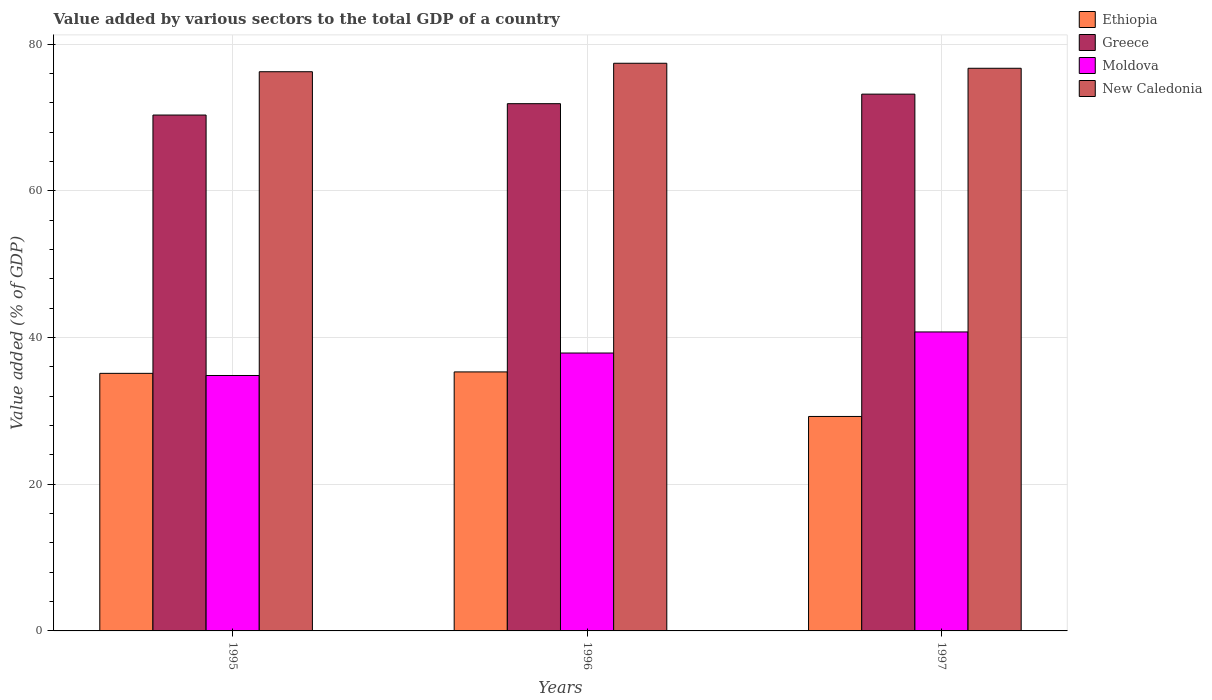How many groups of bars are there?
Offer a terse response. 3. Are the number of bars on each tick of the X-axis equal?
Make the answer very short. Yes. How many bars are there on the 1st tick from the right?
Give a very brief answer. 4. What is the label of the 2nd group of bars from the left?
Offer a terse response. 1996. In how many cases, is the number of bars for a given year not equal to the number of legend labels?
Offer a terse response. 0. What is the value added by various sectors to the total GDP in New Caledonia in 1996?
Make the answer very short. 77.4. Across all years, what is the maximum value added by various sectors to the total GDP in Moldova?
Your answer should be compact. 40.76. Across all years, what is the minimum value added by various sectors to the total GDP in Ethiopia?
Give a very brief answer. 29.24. In which year was the value added by various sectors to the total GDP in Ethiopia minimum?
Your answer should be compact. 1997. What is the total value added by various sectors to the total GDP in Ethiopia in the graph?
Make the answer very short. 99.67. What is the difference between the value added by various sectors to the total GDP in Ethiopia in 1995 and that in 1996?
Provide a short and direct response. -0.2. What is the difference between the value added by various sectors to the total GDP in Ethiopia in 1997 and the value added by various sectors to the total GDP in New Caledonia in 1995?
Your answer should be compact. -47. What is the average value added by various sectors to the total GDP in Moldova per year?
Provide a short and direct response. 37.83. In the year 1995, what is the difference between the value added by various sectors to the total GDP in Ethiopia and value added by various sectors to the total GDP in New Caledonia?
Your response must be concise. -41.12. In how many years, is the value added by various sectors to the total GDP in New Caledonia greater than 36 %?
Keep it short and to the point. 3. What is the ratio of the value added by various sectors to the total GDP in New Caledonia in 1995 to that in 1996?
Keep it short and to the point. 0.99. Is the value added by various sectors to the total GDP in Moldova in 1996 less than that in 1997?
Ensure brevity in your answer.  Yes. What is the difference between the highest and the second highest value added by various sectors to the total GDP in New Caledonia?
Your answer should be very brief. 0.68. What is the difference between the highest and the lowest value added by various sectors to the total GDP in New Caledonia?
Keep it short and to the point. 1.15. In how many years, is the value added by various sectors to the total GDP in Ethiopia greater than the average value added by various sectors to the total GDP in Ethiopia taken over all years?
Your answer should be very brief. 2. Is the sum of the value added by various sectors to the total GDP in Ethiopia in 1996 and 1997 greater than the maximum value added by various sectors to the total GDP in New Caledonia across all years?
Ensure brevity in your answer.  No. What does the 1st bar from the left in 1995 represents?
Provide a short and direct response. Ethiopia. What does the 3rd bar from the right in 1995 represents?
Make the answer very short. Greece. How many bars are there?
Your answer should be compact. 12. Are all the bars in the graph horizontal?
Make the answer very short. No. What is the difference between two consecutive major ticks on the Y-axis?
Your response must be concise. 20. Are the values on the major ticks of Y-axis written in scientific E-notation?
Provide a succinct answer. No. Does the graph contain any zero values?
Your answer should be compact. No. Where does the legend appear in the graph?
Give a very brief answer. Top right. How are the legend labels stacked?
Ensure brevity in your answer.  Vertical. What is the title of the graph?
Your answer should be compact. Value added by various sectors to the total GDP of a country. Does "North America" appear as one of the legend labels in the graph?
Keep it short and to the point. No. What is the label or title of the Y-axis?
Give a very brief answer. Value added (% of GDP). What is the Value added (% of GDP) in Ethiopia in 1995?
Offer a very short reply. 35.12. What is the Value added (% of GDP) in Greece in 1995?
Provide a short and direct response. 70.34. What is the Value added (% of GDP) in Moldova in 1995?
Offer a very short reply. 34.83. What is the Value added (% of GDP) in New Caledonia in 1995?
Make the answer very short. 76.24. What is the Value added (% of GDP) of Ethiopia in 1996?
Offer a very short reply. 35.31. What is the Value added (% of GDP) in Greece in 1996?
Give a very brief answer. 71.89. What is the Value added (% of GDP) of Moldova in 1996?
Make the answer very short. 37.89. What is the Value added (% of GDP) in New Caledonia in 1996?
Offer a terse response. 77.4. What is the Value added (% of GDP) in Ethiopia in 1997?
Provide a succinct answer. 29.24. What is the Value added (% of GDP) in Greece in 1997?
Ensure brevity in your answer.  73.19. What is the Value added (% of GDP) in Moldova in 1997?
Make the answer very short. 40.76. What is the Value added (% of GDP) of New Caledonia in 1997?
Offer a terse response. 76.71. Across all years, what is the maximum Value added (% of GDP) in Ethiopia?
Keep it short and to the point. 35.31. Across all years, what is the maximum Value added (% of GDP) in Greece?
Provide a short and direct response. 73.19. Across all years, what is the maximum Value added (% of GDP) of Moldova?
Offer a terse response. 40.76. Across all years, what is the maximum Value added (% of GDP) of New Caledonia?
Your answer should be compact. 77.4. Across all years, what is the minimum Value added (% of GDP) in Ethiopia?
Provide a succinct answer. 29.24. Across all years, what is the minimum Value added (% of GDP) in Greece?
Offer a very short reply. 70.34. Across all years, what is the minimum Value added (% of GDP) in Moldova?
Your response must be concise. 34.83. Across all years, what is the minimum Value added (% of GDP) of New Caledonia?
Ensure brevity in your answer.  76.24. What is the total Value added (% of GDP) in Ethiopia in the graph?
Provide a short and direct response. 99.67. What is the total Value added (% of GDP) in Greece in the graph?
Your answer should be very brief. 215.41. What is the total Value added (% of GDP) in Moldova in the graph?
Make the answer very short. 113.48. What is the total Value added (% of GDP) in New Caledonia in the graph?
Offer a terse response. 230.36. What is the difference between the Value added (% of GDP) in Ethiopia in 1995 and that in 1996?
Offer a very short reply. -0.2. What is the difference between the Value added (% of GDP) in Greece in 1995 and that in 1996?
Your answer should be compact. -1.55. What is the difference between the Value added (% of GDP) of Moldova in 1995 and that in 1996?
Give a very brief answer. -3.06. What is the difference between the Value added (% of GDP) of New Caledonia in 1995 and that in 1996?
Your answer should be very brief. -1.15. What is the difference between the Value added (% of GDP) in Ethiopia in 1995 and that in 1997?
Offer a terse response. 5.88. What is the difference between the Value added (% of GDP) of Greece in 1995 and that in 1997?
Your answer should be very brief. -2.85. What is the difference between the Value added (% of GDP) in Moldova in 1995 and that in 1997?
Make the answer very short. -5.94. What is the difference between the Value added (% of GDP) of New Caledonia in 1995 and that in 1997?
Offer a very short reply. -0.47. What is the difference between the Value added (% of GDP) of Ethiopia in 1996 and that in 1997?
Your answer should be compact. 6.07. What is the difference between the Value added (% of GDP) of Greece in 1996 and that in 1997?
Provide a short and direct response. -1.3. What is the difference between the Value added (% of GDP) in Moldova in 1996 and that in 1997?
Offer a very short reply. -2.87. What is the difference between the Value added (% of GDP) of New Caledonia in 1996 and that in 1997?
Your response must be concise. 0.68. What is the difference between the Value added (% of GDP) of Ethiopia in 1995 and the Value added (% of GDP) of Greece in 1996?
Offer a very short reply. -36.77. What is the difference between the Value added (% of GDP) of Ethiopia in 1995 and the Value added (% of GDP) of Moldova in 1996?
Your answer should be very brief. -2.77. What is the difference between the Value added (% of GDP) in Ethiopia in 1995 and the Value added (% of GDP) in New Caledonia in 1996?
Provide a short and direct response. -42.28. What is the difference between the Value added (% of GDP) in Greece in 1995 and the Value added (% of GDP) in Moldova in 1996?
Keep it short and to the point. 32.45. What is the difference between the Value added (% of GDP) of Greece in 1995 and the Value added (% of GDP) of New Caledonia in 1996?
Offer a very short reply. -7.06. What is the difference between the Value added (% of GDP) in Moldova in 1995 and the Value added (% of GDP) in New Caledonia in 1996?
Provide a succinct answer. -42.57. What is the difference between the Value added (% of GDP) of Ethiopia in 1995 and the Value added (% of GDP) of Greece in 1997?
Make the answer very short. -38.07. What is the difference between the Value added (% of GDP) in Ethiopia in 1995 and the Value added (% of GDP) in Moldova in 1997?
Ensure brevity in your answer.  -5.65. What is the difference between the Value added (% of GDP) of Ethiopia in 1995 and the Value added (% of GDP) of New Caledonia in 1997?
Make the answer very short. -41.6. What is the difference between the Value added (% of GDP) of Greece in 1995 and the Value added (% of GDP) of Moldova in 1997?
Provide a succinct answer. 29.57. What is the difference between the Value added (% of GDP) in Greece in 1995 and the Value added (% of GDP) in New Caledonia in 1997?
Give a very brief answer. -6.38. What is the difference between the Value added (% of GDP) of Moldova in 1995 and the Value added (% of GDP) of New Caledonia in 1997?
Provide a short and direct response. -41.89. What is the difference between the Value added (% of GDP) in Ethiopia in 1996 and the Value added (% of GDP) in Greece in 1997?
Offer a very short reply. -37.87. What is the difference between the Value added (% of GDP) in Ethiopia in 1996 and the Value added (% of GDP) in Moldova in 1997?
Provide a succinct answer. -5.45. What is the difference between the Value added (% of GDP) of Ethiopia in 1996 and the Value added (% of GDP) of New Caledonia in 1997?
Offer a very short reply. -41.4. What is the difference between the Value added (% of GDP) of Greece in 1996 and the Value added (% of GDP) of Moldova in 1997?
Your answer should be very brief. 31.12. What is the difference between the Value added (% of GDP) of Greece in 1996 and the Value added (% of GDP) of New Caledonia in 1997?
Give a very brief answer. -4.83. What is the difference between the Value added (% of GDP) of Moldova in 1996 and the Value added (% of GDP) of New Caledonia in 1997?
Ensure brevity in your answer.  -38.82. What is the average Value added (% of GDP) of Ethiopia per year?
Ensure brevity in your answer.  33.22. What is the average Value added (% of GDP) of Greece per year?
Provide a short and direct response. 71.8. What is the average Value added (% of GDP) of Moldova per year?
Your response must be concise. 37.83. What is the average Value added (% of GDP) of New Caledonia per year?
Keep it short and to the point. 76.78. In the year 1995, what is the difference between the Value added (% of GDP) in Ethiopia and Value added (% of GDP) in Greece?
Provide a short and direct response. -35.22. In the year 1995, what is the difference between the Value added (% of GDP) in Ethiopia and Value added (% of GDP) in Moldova?
Make the answer very short. 0.29. In the year 1995, what is the difference between the Value added (% of GDP) in Ethiopia and Value added (% of GDP) in New Caledonia?
Your answer should be very brief. -41.12. In the year 1995, what is the difference between the Value added (% of GDP) in Greece and Value added (% of GDP) in Moldova?
Your answer should be very brief. 35.51. In the year 1995, what is the difference between the Value added (% of GDP) of Greece and Value added (% of GDP) of New Caledonia?
Make the answer very short. -5.91. In the year 1995, what is the difference between the Value added (% of GDP) of Moldova and Value added (% of GDP) of New Caledonia?
Offer a terse response. -41.42. In the year 1996, what is the difference between the Value added (% of GDP) in Ethiopia and Value added (% of GDP) in Greece?
Keep it short and to the point. -36.57. In the year 1996, what is the difference between the Value added (% of GDP) in Ethiopia and Value added (% of GDP) in Moldova?
Make the answer very short. -2.58. In the year 1996, what is the difference between the Value added (% of GDP) of Ethiopia and Value added (% of GDP) of New Caledonia?
Ensure brevity in your answer.  -42.08. In the year 1996, what is the difference between the Value added (% of GDP) of Greece and Value added (% of GDP) of Moldova?
Provide a succinct answer. 34. In the year 1996, what is the difference between the Value added (% of GDP) of Greece and Value added (% of GDP) of New Caledonia?
Provide a succinct answer. -5.51. In the year 1996, what is the difference between the Value added (% of GDP) of Moldova and Value added (% of GDP) of New Caledonia?
Ensure brevity in your answer.  -39.51. In the year 1997, what is the difference between the Value added (% of GDP) of Ethiopia and Value added (% of GDP) of Greece?
Your answer should be very brief. -43.95. In the year 1997, what is the difference between the Value added (% of GDP) of Ethiopia and Value added (% of GDP) of Moldova?
Provide a succinct answer. -11.52. In the year 1997, what is the difference between the Value added (% of GDP) in Ethiopia and Value added (% of GDP) in New Caledonia?
Give a very brief answer. -47.47. In the year 1997, what is the difference between the Value added (% of GDP) of Greece and Value added (% of GDP) of Moldova?
Give a very brief answer. 32.43. In the year 1997, what is the difference between the Value added (% of GDP) of Greece and Value added (% of GDP) of New Caledonia?
Your answer should be very brief. -3.52. In the year 1997, what is the difference between the Value added (% of GDP) of Moldova and Value added (% of GDP) of New Caledonia?
Your response must be concise. -35.95. What is the ratio of the Value added (% of GDP) of Greece in 1995 to that in 1996?
Offer a terse response. 0.98. What is the ratio of the Value added (% of GDP) of Moldova in 1995 to that in 1996?
Make the answer very short. 0.92. What is the ratio of the Value added (% of GDP) in New Caledonia in 1995 to that in 1996?
Provide a succinct answer. 0.99. What is the ratio of the Value added (% of GDP) in Ethiopia in 1995 to that in 1997?
Your answer should be very brief. 1.2. What is the ratio of the Value added (% of GDP) of Greece in 1995 to that in 1997?
Your answer should be compact. 0.96. What is the ratio of the Value added (% of GDP) in Moldova in 1995 to that in 1997?
Offer a very short reply. 0.85. What is the ratio of the Value added (% of GDP) of Ethiopia in 1996 to that in 1997?
Keep it short and to the point. 1.21. What is the ratio of the Value added (% of GDP) of Greece in 1996 to that in 1997?
Provide a succinct answer. 0.98. What is the ratio of the Value added (% of GDP) in Moldova in 1996 to that in 1997?
Make the answer very short. 0.93. What is the ratio of the Value added (% of GDP) in New Caledonia in 1996 to that in 1997?
Provide a succinct answer. 1.01. What is the difference between the highest and the second highest Value added (% of GDP) in Ethiopia?
Your answer should be very brief. 0.2. What is the difference between the highest and the second highest Value added (% of GDP) in Greece?
Offer a very short reply. 1.3. What is the difference between the highest and the second highest Value added (% of GDP) in Moldova?
Provide a short and direct response. 2.87. What is the difference between the highest and the second highest Value added (% of GDP) of New Caledonia?
Offer a very short reply. 0.68. What is the difference between the highest and the lowest Value added (% of GDP) of Ethiopia?
Your answer should be very brief. 6.07. What is the difference between the highest and the lowest Value added (% of GDP) of Greece?
Provide a succinct answer. 2.85. What is the difference between the highest and the lowest Value added (% of GDP) of Moldova?
Offer a very short reply. 5.94. What is the difference between the highest and the lowest Value added (% of GDP) of New Caledonia?
Your response must be concise. 1.15. 